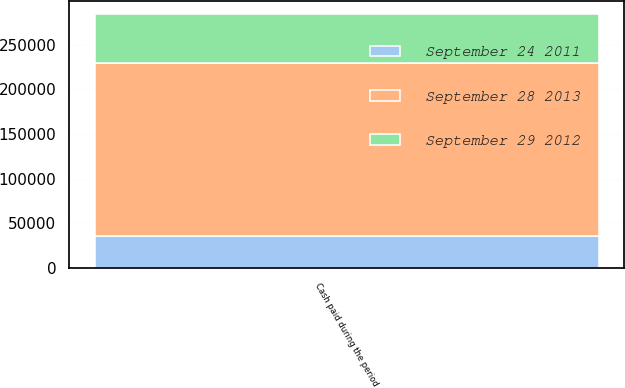Convert chart to OTSL. <chart><loc_0><loc_0><loc_500><loc_500><stacked_bar_chart><ecel><fcel>Cash paid during the period<nl><fcel>September 28 2013<fcel>192794<nl><fcel>September 29 2012<fcel>55045<nl><fcel>September 24 2011<fcel>36268<nl></chart> 